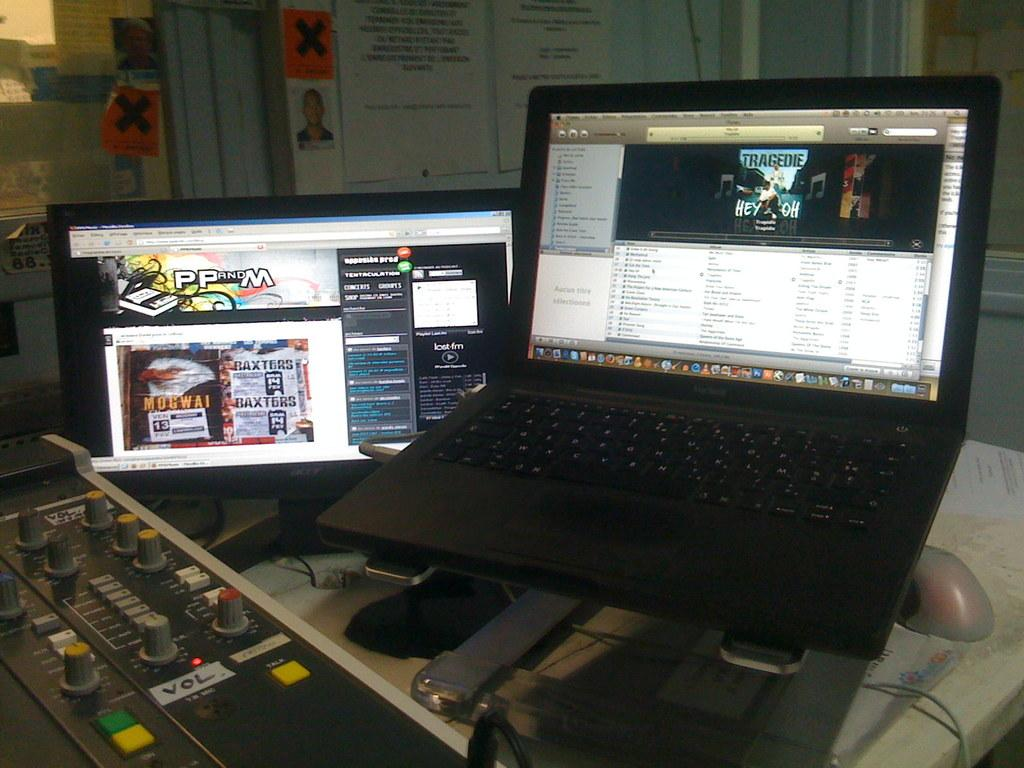<image>
Summarize the visual content of the image. Two screen and the left screen has PP and M on it. 